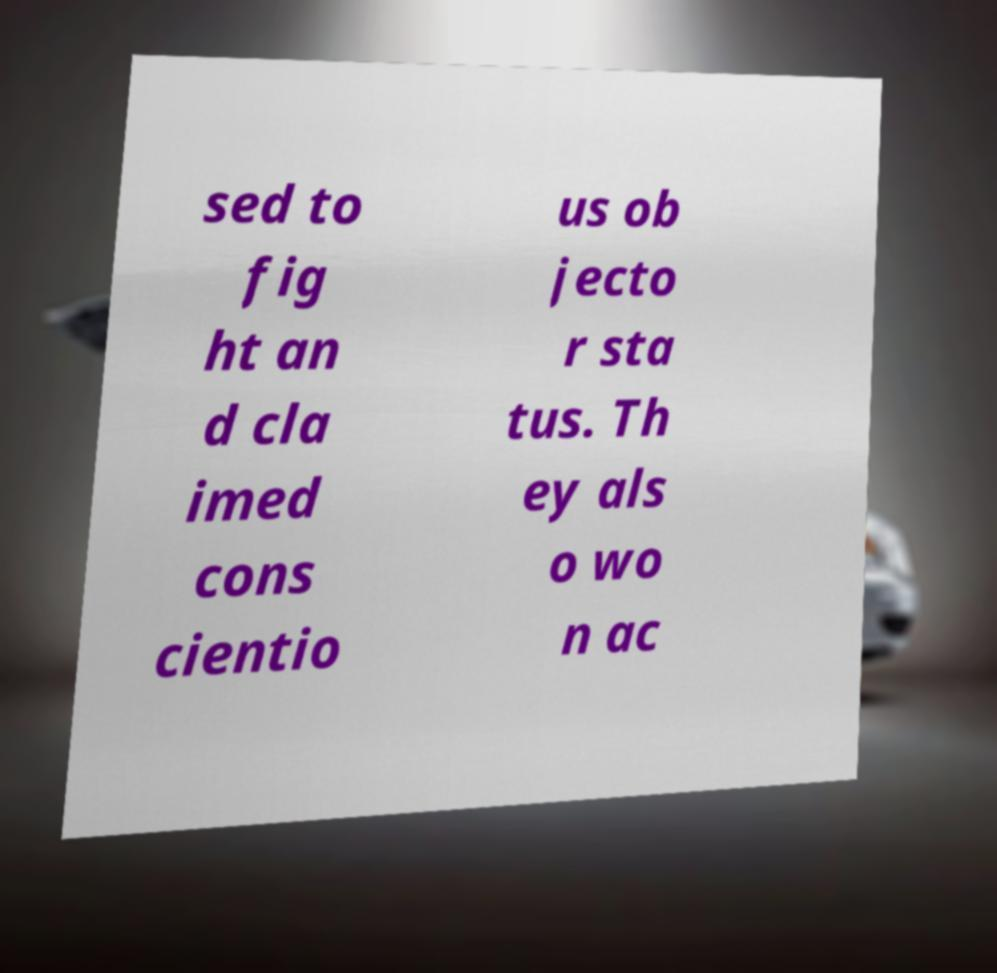Could you extract and type out the text from this image? sed to fig ht an d cla imed cons cientio us ob jecto r sta tus. Th ey als o wo n ac 